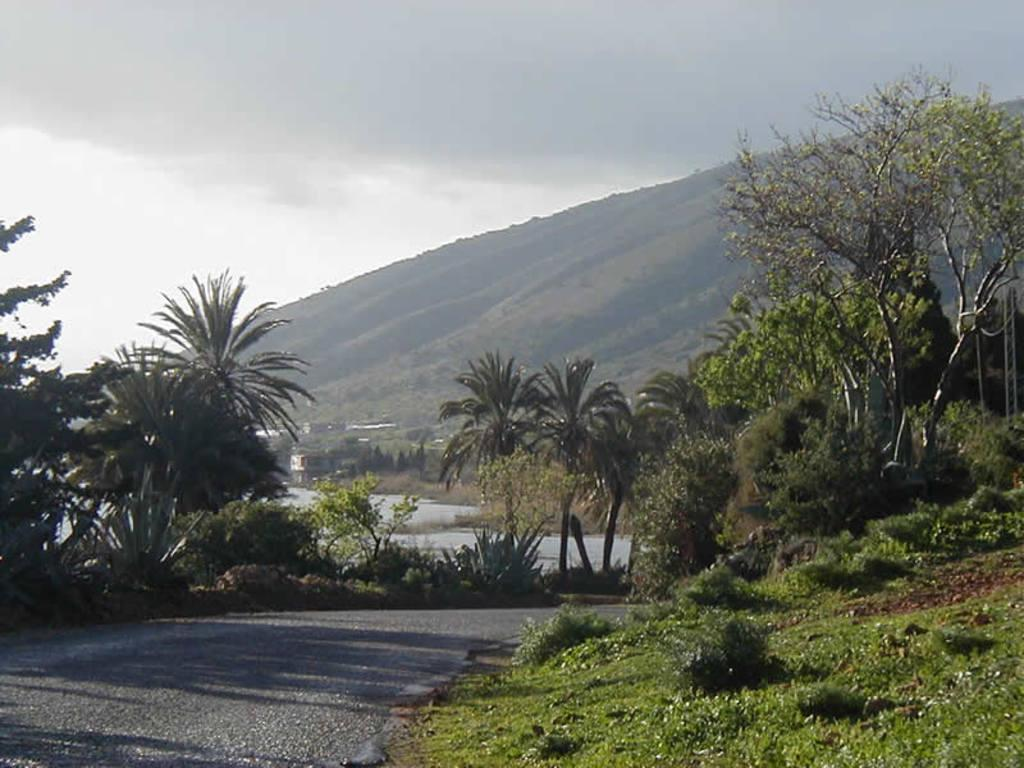What type of natural formation can be seen in the image? There are mountains in the image. What type of man-made structure is present in the image? There is a building in the image. What type of vegetation can be seen in the image? There are trees, plants, and bushes in the image. What type of ground cover is present in the image? There is grass in the image. What is visible at the top of the image? The sky is visible at the top of the image. What type of pathway is present in the image? There is a road in the image. What type of beam is holding up the mountains in the image? There is no beam present in the image; the mountains are a natural formation and do not require any support. How does the plane navigate through the mountains in the image? There is no plane present in the image; the focus is on the mountains, road, and vegetation. 